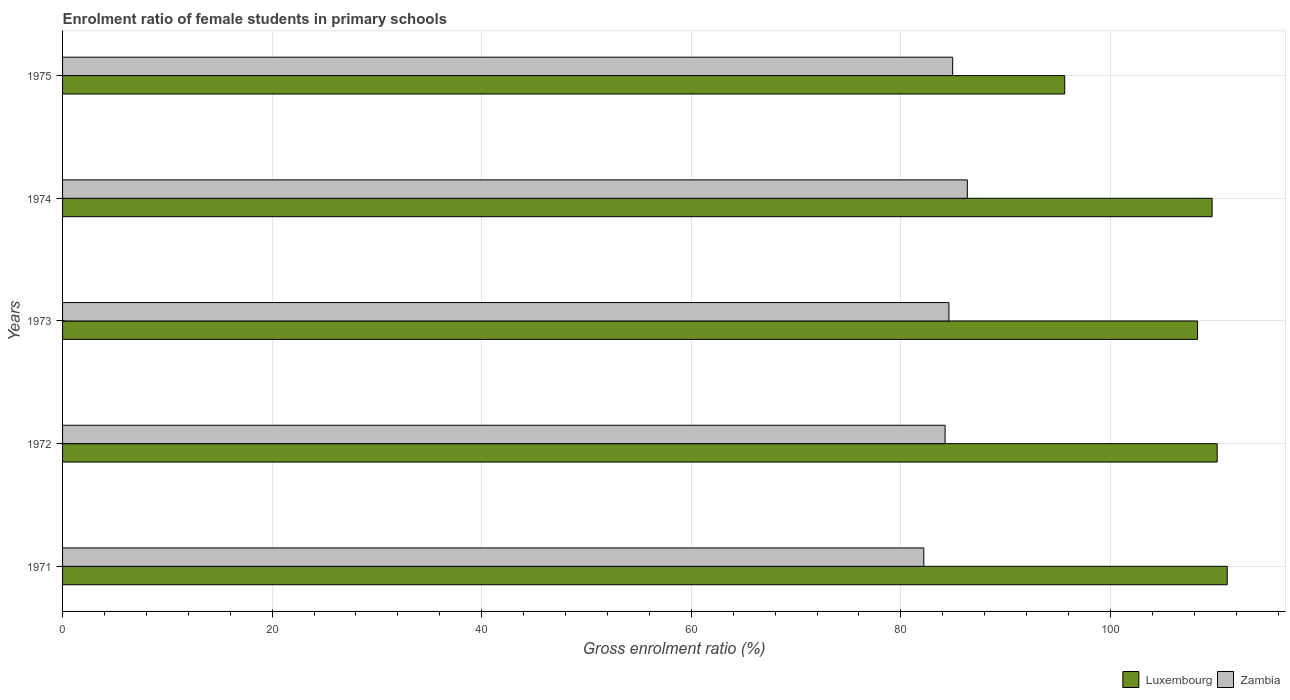How many different coloured bars are there?
Offer a terse response. 2. How many groups of bars are there?
Offer a very short reply. 5. What is the label of the 5th group of bars from the top?
Provide a short and direct response. 1971. In how many cases, is the number of bars for a given year not equal to the number of legend labels?
Ensure brevity in your answer.  0. What is the enrolment ratio of female students in primary schools in Luxembourg in 1973?
Your response must be concise. 108.31. Across all years, what is the maximum enrolment ratio of female students in primary schools in Luxembourg?
Your response must be concise. 111.15. Across all years, what is the minimum enrolment ratio of female students in primary schools in Zambia?
Provide a short and direct response. 82.19. In which year was the enrolment ratio of female students in primary schools in Zambia minimum?
Your response must be concise. 1971. What is the total enrolment ratio of female students in primary schools in Luxembourg in the graph?
Offer a very short reply. 534.97. What is the difference between the enrolment ratio of female students in primary schools in Luxembourg in 1971 and that in 1972?
Your answer should be very brief. 0.96. What is the difference between the enrolment ratio of female students in primary schools in Luxembourg in 1973 and the enrolment ratio of female students in primary schools in Zambia in 1972?
Your answer should be very brief. 24.09. What is the average enrolment ratio of female students in primary schools in Zambia per year?
Provide a short and direct response. 84.45. In the year 1973, what is the difference between the enrolment ratio of female students in primary schools in Zambia and enrolment ratio of female students in primary schools in Luxembourg?
Your response must be concise. -23.73. In how many years, is the enrolment ratio of female students in primary schools in Luxembourg greater than 52 %?
Your answer should be compact. 5. What is the ratio of the enrolment ratio of female students in primary schools in Luxembourg in 1972 to that in 1975?
Make the answer very short. 1.15. Is the difference between the enrolment ratio of female students in primary schools in Zambia in 1971 and 1973 greater than the difference between the enrolment ratio of female students in primary schools in Luxembourg in 1971 and 1973?
Provide a succinct answer. No. What is the difference between the highest and the second highest enrolment ratio of female students in primary schools in Zambia?
Keep it short and to the point. 1.4. What is the difference between the highest and the lowest enrolment ratio of female students in primary schools in Luxembourg?
Provide a short and direct response. 15.51. In how many years, is the enrolment ratio of female students in primary schools in Luxembourg greater than the average enrolment ratio of female students in primary schools in Luxembourg taken over all years?
Your response must be concise. 4. Is the sum of the enrolment ratio of female students in primary schools in Luxembourg in 1971 and 1972 greater than the maximum enrolment ratio of female students in primary schools in Zambia across all years?
Your response must be concise. Yes. What does the 1st bar from the top in 1975 represents?
Provide a succinct answer. Zambia. What does the 1st bar from the bottom in 1974 represents?
Provide a succinct answer. Luxembourg. How many bars are there?
Your answer should be compact. 10. Are the values on the major ticks of X-axis written in scientific E-notation?
Offer a very short reply. No. Does the graph contain any zero values?
Keep it short and to the point. No. Where does the legend appear in the graph?
Keep it short and to the point. Bottom right. How many legend labels are there?
Provide a succinct answer. 2. How are the legend labels stacked?
Your response must be concise. Horizontal. What is the title of the graph?
Make the answer very short. Enrolment ratio of female students in primary schools. What is the label or title of the X-axis?
Your answer should be compact. Gross enrolment ratio (%). What is the Gross enrolment ratio (%) in Luxembourg in 1971?
Your answer should be very brief. 111.15. What is the Gross enrolment ratio (%) of Zambia in 1971?
Your answer should be very brief. 82.19. What is the Gross enrolment ratio (%) of Luxembourg in 1972?
Provide a succinct answer. 110.18. What is the Gross enrolment ratio (%) in Zambia in 1972?
Offer a very short reply. 84.22. What is the Gross enrolment ratio (%) in Luxembourg in 1973?
Provide a succinct answer. 108.31. What is the Gross enrolment ratio (%) of Zambia in 1973?
Give a very brief answer. 84.58. What is the Gross enrolment ratio (%) in Luxembourg in 1974?
Give a very brief answer. 109.7. What is the Gross enrolment ratio (%) in Zambia in 1974?
Give a very brief answer. 86.34. What is the Gross enrolment ratio (%) in Luxembourg in 1975?
Provide a short and direct response. 95.63. What is the Gross enrolment ratio (%) in Zambia in 1975?
Your answer should be compact. 84.94. Across all years, what is the maximum Gross enrolment ratio (%) in Luxembourg?
Offer a terse response. 111.15. Across all years, what is the maximum Gross enrolment ratio (%) in Zambia?
Your answer should be compact. 86.34. Across all years, what is the minimum Gross enrolment ratio (%) of Luxembourg?
Your answer should be compact. 95.63. Across all years, what is the minimum Gross enrolment ratio (%) of Zambia?
Give a very brief answer. 82.19. What is the total Gross enrolment ratio (%) of Luxembourg in the graph?
Your response must be concise. 534.97. What is the total Gross enrolment ratio (%) of Zambia in the graph?
Keep it short and to the point. 422.27. What is the difference between the Gross enrolment ratio (%) of Luxembourg in 1971 and that in 1972?
Give a very brief answer. 0.96. What is the difference between the Gross enrolment ratio (%) in Zambia in 1971 and that in 1972?
Give a very brief answer. -2.03. What is the difference between the Gross enrolment ratio (%) in Luxembourg in 1971 and that in 1973?
Make the answer very short. 2.83. What is the difference between the Gross enrolment ratio (%) in Zambia in 1971 and that in 1973?
Offer a terse response. -2.4. What is the difference between the Gross enrolment ratio (%) of Luxembourg in 1971 and that in 1974?
Keep it short and to the point. 1.45. What is the difference between the Gross enrolment ratio (%) of Zambia in 1971 and that in 1974?
Your response must be concise. -4.15. What is the difference between the Gross enrolment ratio (%) of Luxembourg in 1971 and that in 1975?
Ensure brevity in your answer.  15.51. What is the difference between the Gross enrolment ratio (%) in Zambia in 1971 and that in 1975?
Make the answer very short. -2.75. What is the difference between the Gross enrolment ratio (%) in Luxembourg in 1972 and that in 1973?
Your answer should be very brief. 1.87. What is the difference between the Gross enrolment ratio (%) of Zambia in 1972 and that in 1973?
Make the answer very short. -0.37. What is the difference between the Gross enrolment ratio (%) of Luxembourg in 1972 and that in 1974?
Offer a terse response. 0.49. What is the difference between the Gross enrolment ratio (%) of Zambia in 1972 and that in 1974?
Provide a succinct answer. -2.12. What is the difference between the Gross enrolment ratio (%) of Luxembourg in 1972 and that in 1975?
Your answer should be compact. 14.55. What is the difference between the Gross enrolment ratio (%) in Zambia in 1972 and that in 1975?
Your answer should be compact. -0.72. What is the difference between the Gross enrolment ratio (%) in Luxembourg in 1973 and that in 1974?
Ensure brevity in your answer.  -1.39. What is the difference between the Gross enrolment ratio (%) of Zambia in 1973 and that in 1974?
Your answer should be compact. -1.76. What is the difference between the Gross enrolment ratio (%) in Luxembourg in 1973 and that in 1975?
Ensure brevity in your answer.  12.68. What is the difference between the Gross enrolment ratio (%) of Zambia in 1973 and that in 1975?
Provide a short and direct response. -0.36. What is the difference between the Gross enrolment ratio (%) in Luxembourg in 1974 and that in 1975?
Your answer should be very brief. 14.07. What is the difference between the Gross enrolment ratio (%) of Zambia in 1974 and that in 1975?
Your answer should be compact. 1.4. What is the difference between the Gross enrolment ratio (%) in Luxembourg in 1971 and the Gross enrolment ratio (%) in Zambia in 1972?
Provide a short and direct response. 26.93. What is the difference between the Gross enrolment ratio (%) in Luxembourg in 1971 and the Gross enrolment ratio (%) in Zambia in 1973?
Provide a succinct answer. 26.56. What is the difference between the Gross enrolment ratio (%) of Luxembourg in 1971 and the Gross enrolment ratio (%) of Zambia in 1974?
Offer a very short reply. 24.8. What is the difference between the Gross enrolment ratio (%) in Luxembourg in 1971 and the Gross enrolment ratio (%) in Zambia in 1975?
Provide a succinct answer. 26.2. What is the difference between the Gross enrolment ratio (%) of Luxembourg in 1972 and the Gross enrolment ratio (%) of Zambia in 1973?
Your answer should be compact. 25.6. What is the difference between the Gross enrolment ratio (%) in Luxembourg in 1972 and the Gross enrolment ratio (%) in Zambia in 1974?
Ensure brevity in your answer.  23.84. What is the difference between the Gross enrolment ratio (%) of Luxembourg in 1972 and the Gross enrolment ratio (%) of Zambia in 1975?
Give a very brief answer. 25.24. What is the difference between the Gross enrolment ratio (%) of Luxembourg in 1973 and the Gross enrolment ratio (%) of Zambia in 1974?
Offer a terse response. 21.97. What is the difference between the Gross enrolment ratio (%) of Luxembourg in 1973 and the Gross enrolment ratio (%) of Zambia in 1975?
Give a very brief answer. 23.37. What is the difference between the Gross enrolment ratio (%) of Luxembourg in 1974 and the Gross enrolment ratio (%) of Zambia in 1975?
Offer a very short reply. 24.76. What is the average Gross enrolment ratio (%) in Luxembourg per year?
Your response must be concise. 106.99. What is the average Gross enrolment ratio (%) of Zambia per year?
Offer a very short reply. 84.45. In the year 1971, what is the difference between the Gross enrolment ratio (%) in Luxembourg and Gross enrolment ratio (%) in Zambia?
Keep it short and to the point. 28.96. In the year 1972, what is the difference between the Gross enrolment ratio (%) of Luxembourg and Gross enrolment ratio (%) of Zambia?
Offer a very short reply. 25.96. In the year 1973, what is the difference between the Gross enrolment ratio (%) in Luxembourg and Gross enrolment ratio (%) in Zambia?
Provide a succinct answer. 23.73. In the year 1974, what is the difference between the Gross enrolment ratio (%) in Luxembourg and Gross enrolment ratio (%) in Zambia?
Offer a terse response. 23.36. In the year 1975, what is the difference between the Gross enrolment ratio (%) in Luxembourg and Gross enrolment ratio (%) in Zambia?
Provide a succinct answer. 10.69. What is the ratio of the Gross enrolment ratio (%) of Luxembourg in 1971 to that in 1972?
Offer a terse response. 1.01. What is the ratio of the Gross enrolment ratio (%) of Zambia in 1971 to that in 1972?
Your answer should be compact. 0.98. What is the ratio of the Gross enrolment ratio (%) of Luxembourg in 1971 to that in 1973?
Your answer should be compact. 1.03. What is the ratio of the Gross enrolment ratio (%) of Zambia in 1971 to that in 1973?
Make the answer very short. 0.97. What is the ratio of the Gross enrolment ratio (%) of Luxembourg in 1971 to that in 1974?
Your answer should be compact. 1.01. What is the ratio of the Gross enrolment ratio (%) of Zambia in 1971 to that in 1974?
Offer a terse response. 0.95. What is the ratio of the Gross enrolment ratio (%) in Luxembourg in 1971 to that in 1975?
Offer a very short reply. 1.16. What is the ratio of the Gross enrolment ratio (%) of Zambia in 1971 to that in 1975?
Your response must be concise. 0.97. What is the ratio of the Gross enrolment ratio (%) of Luxembourg in 1972 to that in 1973?
Offer a terse response. 1.02. What is the ratio of the Gross enrolment ratio (%) in Zambia in 1972 to that in 1973?
Offer a terse response. 1. What is the ratio of the Gross enrolment ratio (%) of Luxembourg in 1972 to that in 1974?
Keep it short and to the point. 1. What is the ratio of the Gross enrolment ratio (%) of Zambia in 1972 to that in 1974?
Provide a succinct answer. 0.98. What is the ratio of the Gross enrolment ratio (%) of Luxembourg in 1972 to that in 1975?
Your response must be concise. 1.15. What is the ratio of the Gross enrolment ratio (%) in Zambia in 1972 to that in 1975?
Provide a succinct answer. 0.99. What is the ratio of the Gross enrolment ratio (%) in Luxembourg in 1973 to that in 1974?
Provide a short and direct response. 0.99. What is the ratio of the Gross enrolment ratio (%) in Zambia in 1973 to that in 1974?
Your answer should be compact. 0.98. What is the ratio of the Gross enrolment ratio (%) of Luxembourg in 1973 to that in 1975?
Make the answer very short. 1.13. What is the ratio of the Gross enrolment ratio (%) of Zambia in 1973 to that in 1975?
Give a very brief answer. 1. What is the ratio of the Gross enrolment ratio (%) in Luxembourg in 1974 to that in 1975?
Provide a short and direct response. 1.15. What is the ratio of the Gross enrolment ratio (%) in Zambia in 1974 to that in 1975?
Provide a short and direct response. 1.02. What is the difference between the highest and the second highest Gross enrolment ratio (%) of Luxembourg?
Provide a short and direct response. 0.96. What is the difference between the highest and the second highest Gross enrolment ratio (%) of Zambia?
Your answer should be compact. 1.4. What is the difference between the highest and the lowest Gross enrolment ratio (%) of Luxembourg?
Provide a succinct answer. 15.51. What is the difference between the highest and the lowest Gross enrolment ratio (%) of Zambia?
Give a very brief answer. 4.15. 